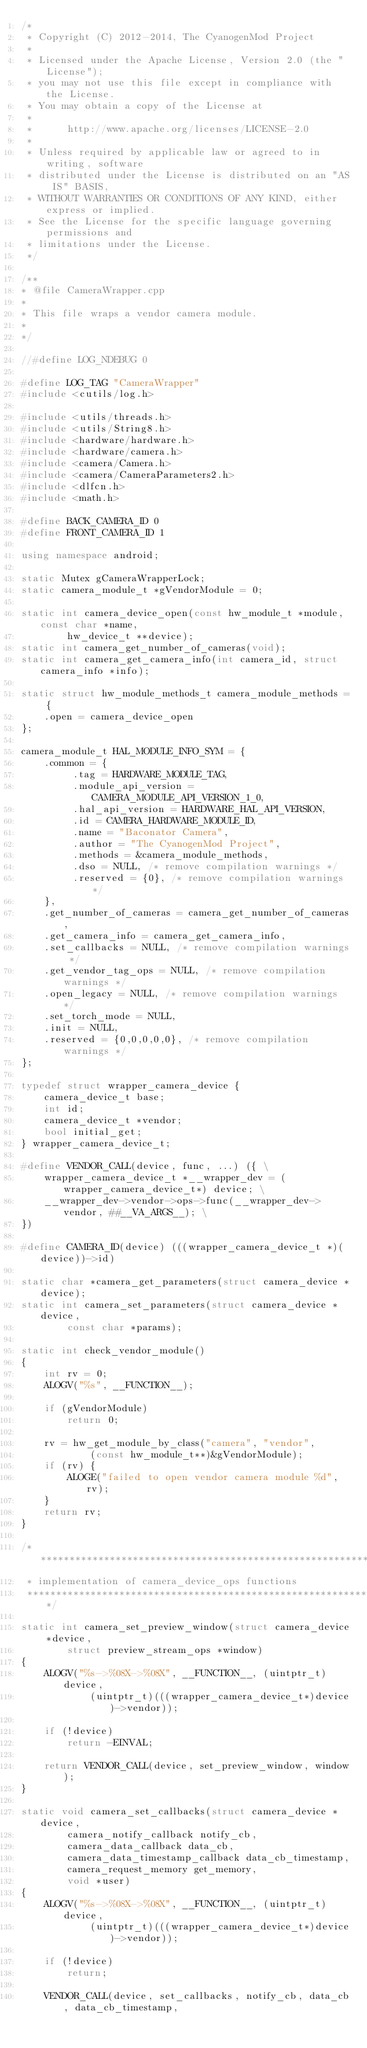<code> <loc_0><loc_0><loc_500><loc_500><_C++_>/*
 * Copyright (C) 2012-2014, The CyanogenMod Project
 *
 * Licensed under the Apache License, Version 2.0 (the "License");
 * you may not use this file except in compliance with the License.
 * You may obtain a copy of the License at
 *
 *      http://www.apache.org/licenses/LICENSE-2.0
 *
 * Unless required by applicable law or agreed to in writing, software
 * distributed under the License is distributed on an "AS IS" BASIS,
 * WITHOUT WARRANTIES OR CONDITIONS OF ANY KIND, either express or implied.
 * See the License for the specific language governing permissions and
 * limitations under the License.
 */

/**
* @file CameraWrapper.cpp
*
* This file wraps a vendor camera module.
*
*/

//#define LOG_NDEBUG 0

#define LOG_TAG "CameraWrapper"
#include <cutils/log.h>

#include <utils/threads.h>
#include <utils/String8.h>
#include <hardware/hardware.h>
#include <hardware/camera.h>
#include <camera/Camera.h>
#include <camera/CameraParameters2.h>
#include <dlfcn.h>
#include <math.h>

#define BACK_CAMERA_ID 0
#define FRONT_CAMERA_ID 1

using namespace android;

static Mutex gCameraWrapperLock;
static camera_module_t *gVendorModule = 0;

static int camera_device_open(const hw_module_t *module, const char *name,
        hw_device_t **device);
static int camera_get_number_of_cameras(void);
static int camera_get_camera_info(int camera_id, struct camera_info *info);

static struct hw_module_methods_t camera_module_methods = {
    .open = camera_device_open
};

camera_module_t HAL_MODULE_INFO_SYM = {
    .common = {
         .tag = HARDWARE_MODULE_TAG,
         .module_api_version = CAMERA_MODULE_API_VERSION_1_0,
         .hal_api_version = HARDWARE_HAL_API_VERSION,
         .id = CAMERA_HARDWARE_MODULE_ID,
         .name = "Baconator Camera",
         .author = "The CyanogenMod Project",
         .methods = &camera_module_methods,
         .dso = NULL, /* remove compilation warnings */
         .reserved = {0}, /* remove compilation warnings */
    },
    .get_number_of_cameras = camera_get_number_of_cameras,
    .get_camera_info = camera_get_camera_info,
    .set_callbacks = NULL, /* remove compilation warnings */
    .get_vendor_tag_ops = NULL, /* remove compilation warnings */
    .open_legacy = NULL, /* remove compilation warnings */
    .set_torch_mode = NULL,
    .init = NULL,
    .reserved = {0,0,0,0,0}, /* remove compilation warnings */
};

typedef struct wrapper_camera_device {
    camera_device_t base;
    int id;
    camera_device_t *vendor;
    bool initial_get;
} wrapper_camera_device_t;

#define VENDOR_CALL(device, func, ...) ({ \
    wrapper_camera_device_t *__wrapper_dev = (wrapper_camera_device_t*) device; \
    __wrapper_dev->vendor->ops->func(__wrapper_dev->vendor, ##__VA_ARGS__); \
})

#define CAMERA_ID(device) (((wrapper_camera_device_t *)(device))->id)

static char *camera_get_parameters(struct camera_device *device);
static int camera_set_parameters(struct camera_device *device,
        const char *params);

static int check_vendor_module()
{
    int rv = 0;
    ALOGV("%s", __FUNCTION__);

    if (gVendorModule)
        return 0;

    rv = hw_get_module_by_class("camera", "vendor",
            (const hw_module_t**)&gVendorModule);
    if (rv) {
        ALOGE("failed to open vendor camera module %d", rv);
    }
    return rv;
}

/*******************************************************************
 * implementation of camera_device_ops functions
 *******************************************************************/

static int camera_set_preview_window(struct camera_device *device,
        struct preview_stream_ops *window)
{
    ALOGV("%s->%08X->%08X", __FUNCTION__, (uintptr_t)device,
            (uintptr_t)(((wrapper_camera_device_t*)device)->vendor));

    if (!device)
        return -EINVAL;

    return VENDOR_CALL(device, set_preview_window, window);
}

static void camera_set_callbacks(struct camera_device *device,
        camera_notify_callback notify_cb,
        camera_data_callback data_cb,
        camera_data_timestamp_callback data_cb_timestamp,
        camera_request_memory get_memory,
        void *user)
{
    ALOGV("%s->%08X->%08X", __FUNCTION__, (uintptr_t)device,
            (uintptr_t)(((wrapper_camera_device_t*)device)->vendor));

    if (!device)
        return;

    VENDOR_CALL(device, set_callbacks, notify_cb, data_cb, data_cb_timestamp,</code> 